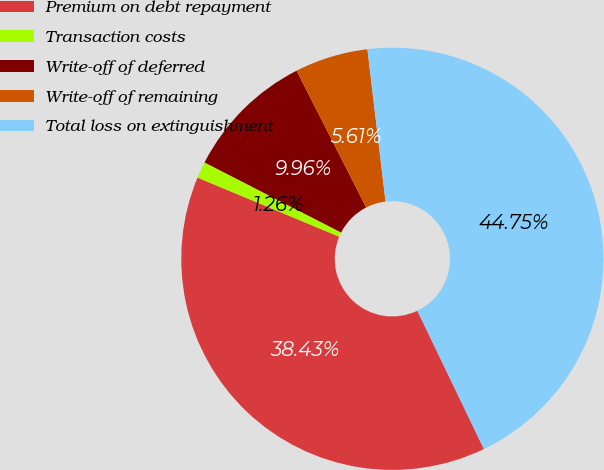Convert chart. <chart><loc_0><loc_0><loc_500><loc_500><pie_chart><fcel>Premium on debt repayment<fcel>Transaction costs<fcel>Write-off of deferred<fcel>Write-off of remaining<fcel>Total loss on extinguishment<nl><fcel>38.43%<fcel>1.26%<fcel>9.96%<fcel>5.61%<fcel>44.75%<nl></chart> 